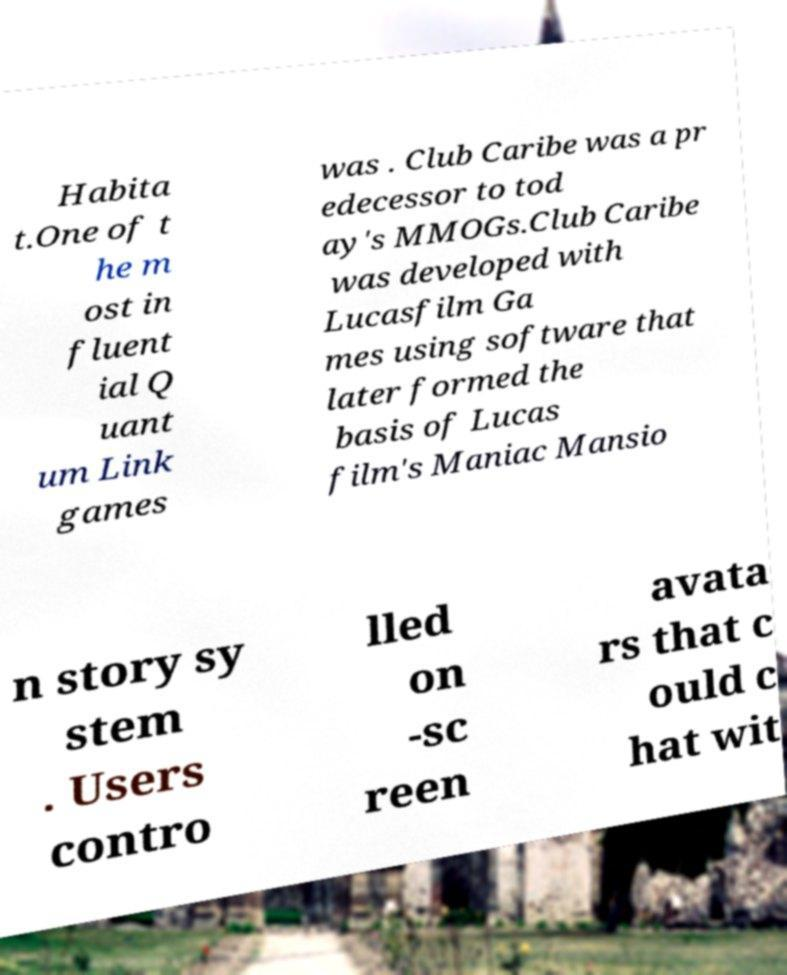What messages or text are displayed in this image? I need them in a readable, typed format. Habita t.One of t he m ost in fluent ial Q uant um Link games was . Club Caribe was a pr edecessor to tod ay's MMOGs.Club Caribe was developed with Lucasfilm Ga mes using software that later formed the basis of Lucas film's Maniac Mansio n story sy stem . Users contro lled on -sc reen avata rs that c ould c hat wit 